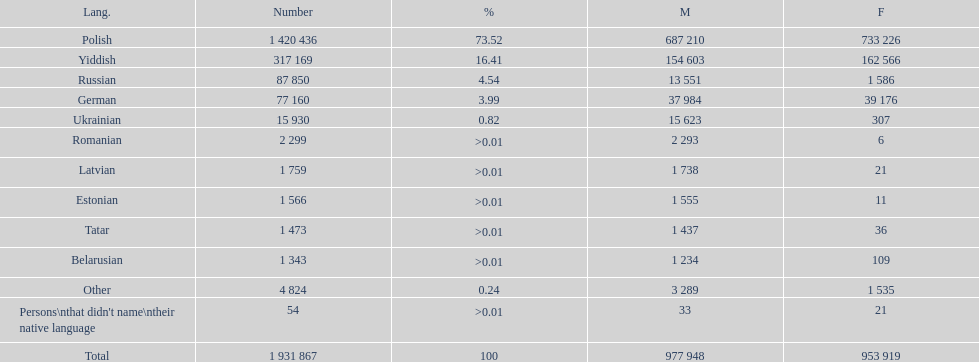What is the highest percentage of speakers other than polish? Yiddish. 